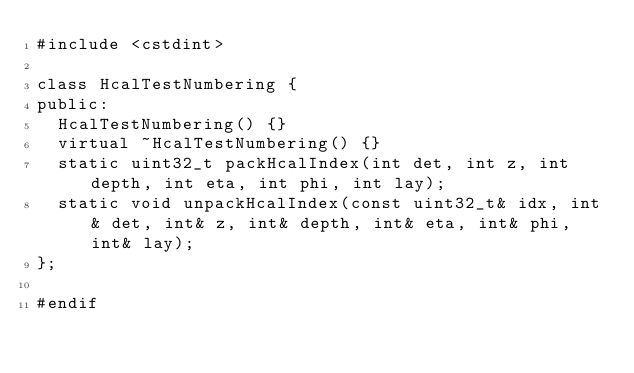Convert code to text. <code><loc_0><loc_0><loc_500><loc_500><_C_>#include <cstdint>

class HcalTestNumbering {
public:
  HcalTestNumbering() {}
  virtual ~HcalTestNumbering() {}
  static uint32_t packHcalIndex(int det, int z, int depth, int eta, int phi, int lay);
  static void unpackHcalIndex(const uint32_t& idx, int& det, int& z, int& depth, int& eta, int& phi, int& lay);
};

#endif
</code> 